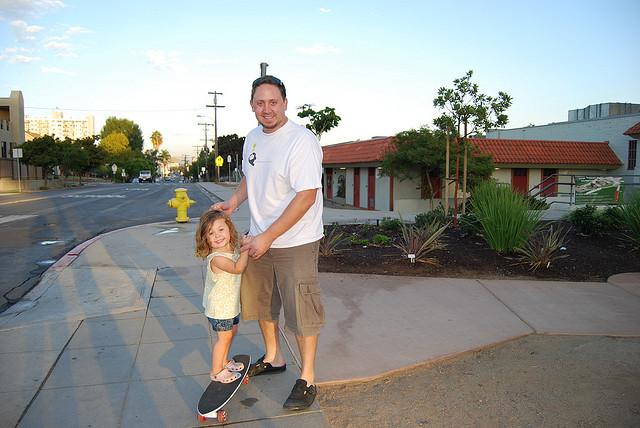What are the reddish and green plants called in the forefront of the planter? Please explain your reasoning. flax. There is a young girl posing with her dad. there standing in front of some plants that are pointy bushes as well as trees. 